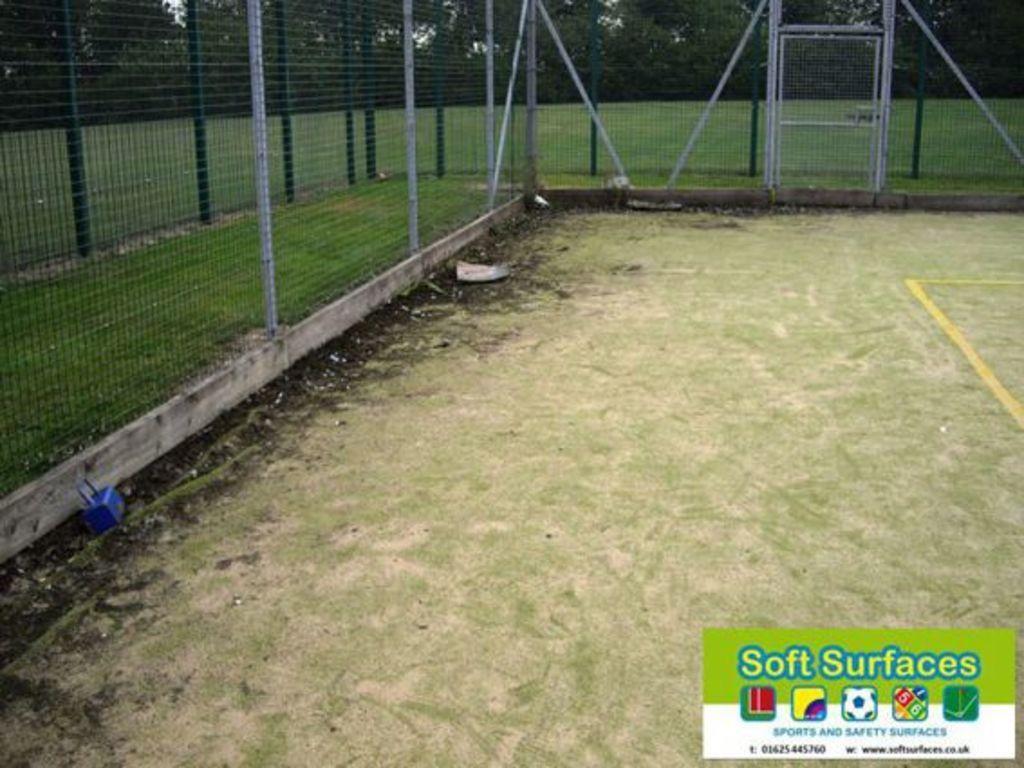Could you give a brief overview of what you see in this image? In this picture I can see a ground on which we can see a grass and also we can see fencing to the both sides, behind we can see some trees. 